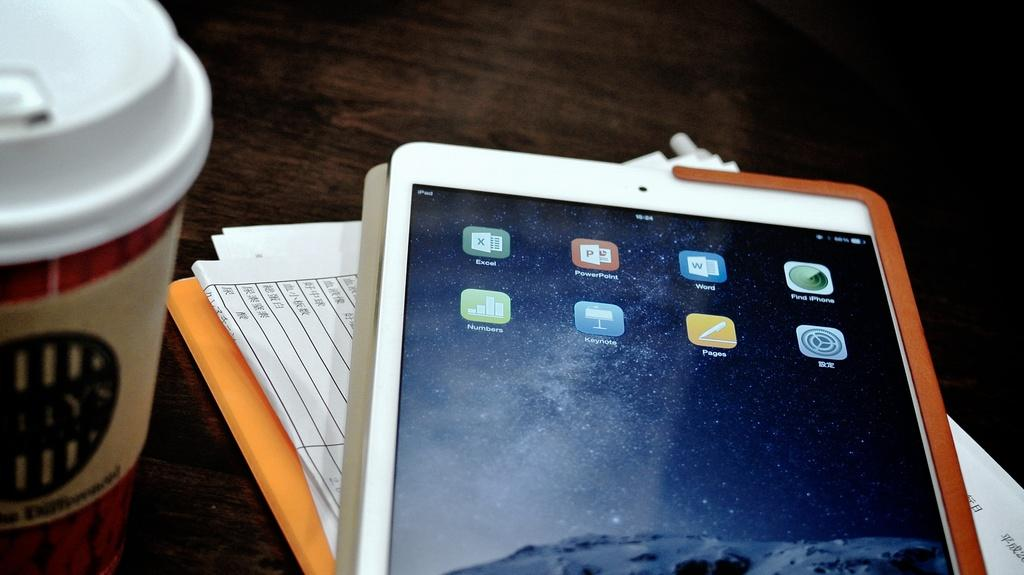What object can be seen hanging in the image? There is a mobile in the image. What type of items are on the table in the image? There are papers and a glass on the table in the image. What is the color of the table in the image? The table is brown in color. Can you see any sea creatures in the image? There are no sea creatures present in the image. Is there a lamp on the table in the image? There is no lamp present in the image. 